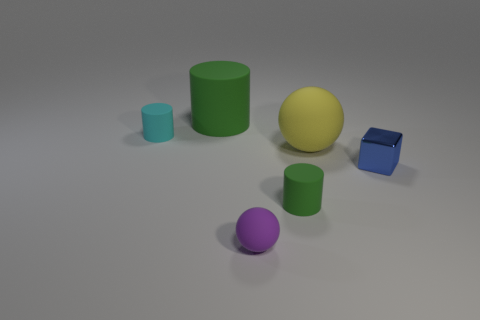How many blue objects are big rubber spheres or spheres?
Keep it short and to the point. 0. How many other cylinders are the same color as the large matte cylinder?
Provide a short and direct response. 1. Is the material of the yellow object the same as the blue thing?
Your answer should be compact. No. There is a green matte object that is on the left side of the purple object; what number of green cylinders are in front of it?
Make the answer very short. 1. Do the cube and the purple sphere have the same size?
Provide a short and direct response. Yes. What number of cyan things have the same material as the cube?
Offer a very short reply. 0. There is a cyan object that is the same shape as the large green rubber object; what is its size?
Your answer should be compact. Small. There is a large thing that is to the right of the purple matte ball; is it the same shape as the tiny green matte object?
Ensure brevity in your answer.  No. There is a green rubber object that is right of the green rubber cylinder behind the yellow sphere; what shape is it?
Offer a terse response. Cylinder. Are there any other things that have the same shape as the blue thing?
Offer a terse response. No. 